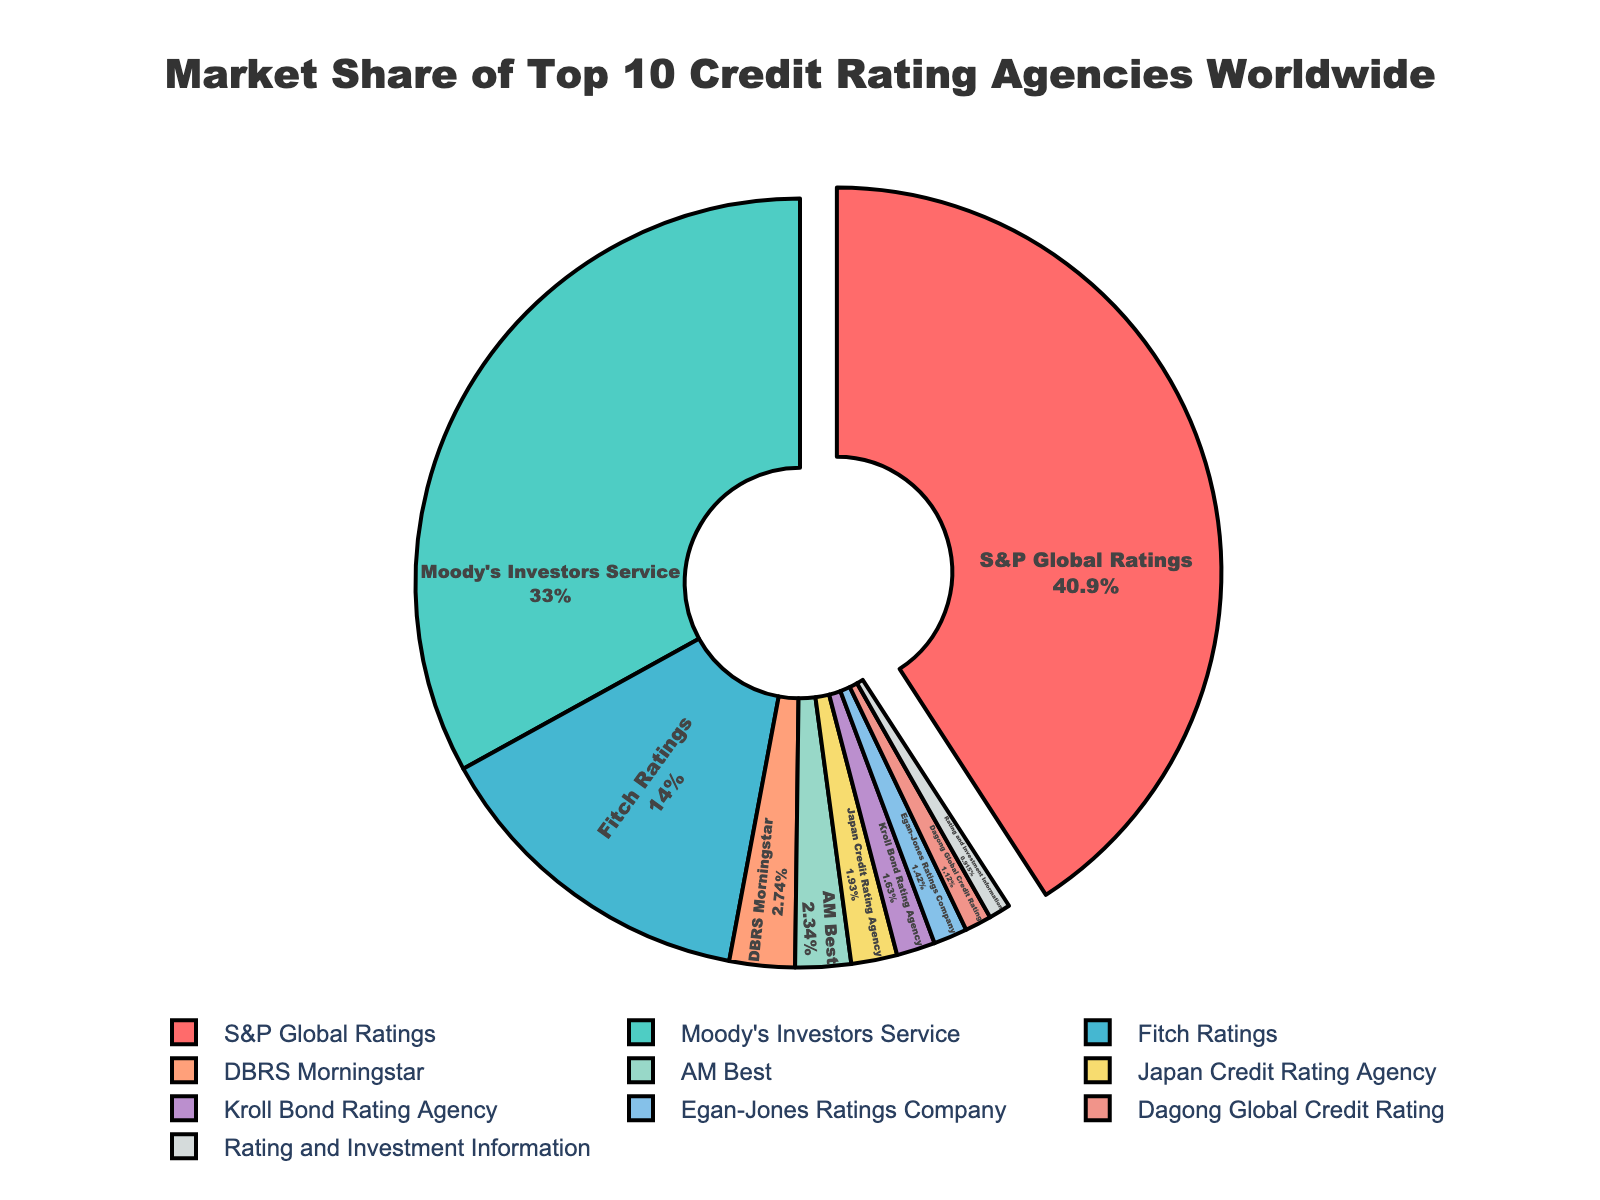Which company has the highest market share? The figure shows that S&P Global Ratings has the largest segment with the highest percentage label.
Answer: S&P Global Ratings What's the combined market share of the top 3 companies? S&P Global Ratings has 40.2%, Moody's Investors Service has 32.5%, and Fitch Ratings has 13.8%. Adding these together: 40.2 + 32.5 + 13.8 = 86.5.
Answer: 86.5% How much larger is S&P Global Ratings' market share compared to AM Best? S&P Global Ratings has a market share of 40.2%, and AM Best has 2.3%. The difference is 40.2 - 2.3 = 37.9.
Answer: 37.9% Which segment is represented in a bright red color? By visual inspection, the segment for S&P Global Ratings is in bright red.
Answer: S&P Global Ratings What proportion of the market do agencies with less than 2% market share collectively hold? Agencies with less than 2% are Japan Credit Rating Agency (1.9%), Kroll Bond Rating Agency (1.6%), Egan-Jones Ratings Company (1.4%), Dagong Global Credit Rating (1.1%), and Rating and Investment Information (0.9%). Summing these: 1.9 + 1.6 + 1.4 + 1.1 + 0.9 = 6.9.
Answer: 6.9% Which agency has the smallest market share and what is it? The smallest market share is held by Rating and Investment Information, which is 0.9%.
Answer: Rating and Investment Information, 0.9% Is the combined market share of Moody's Investors Service, Fitch Ratings, and DBRS Morningstar greater than S&P Global Ratings? Moody's has 32.5%, Fitch Ratings has 13.8%, and DBRS Morningstar has 2.7%. Adding these: 32.5 + 13.8 + 2.7 = 49. Comparing with S&P Global Ratings' 40.2%: 49 > 40.2.
Answer: Yes Which companies have a market share between 1% and 2%, and what are their shares? Companies with market shares between 1% and 2% are Japan Credit Rating Agency (1.9%), Kroll Bond Rating Agency (1.6%), Egan-Jones Ratings Company (1.4%), and Dagong Global Credit Rating (1.1%).
Answer: Japan Credit Rating Agency (1.9%), Kroll Bond Rating Agency (1.6%), Egan-Jones Ratings Company (1.4%), Dagong Global Credit Rating (1.1%) How does the market share of Fitch Ratings compare to the market share of Moody's Investors Service? Fitch Ratings has a market share of 13.8%, while Moody's Investors Service has a market share of 32.5%. Fitch Ratings' share is less than Moody's by 32.5 - 13.8 = 18.7.
Answer: Less by 18.7% What is the average market share of the companies listed? The total market share of all companies is 100%, and there are 10 companies. The average market share is 100 / 10 = 10.
Answer: 10% 